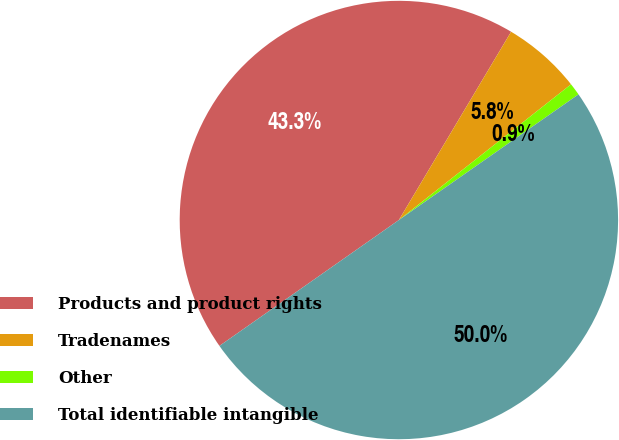Convert chart to OTSL. <chart><loc_0><loc_0><loc_500><loc_500><pie_chart><fcel>Products and product rights<fcel>Tradenames<fcel>Other<fcel>Total identifiable intangible<nl><fcel>43.29%<fcel>5.82%<fcel>0.91%<fcel>49.98%<nl></chart> 